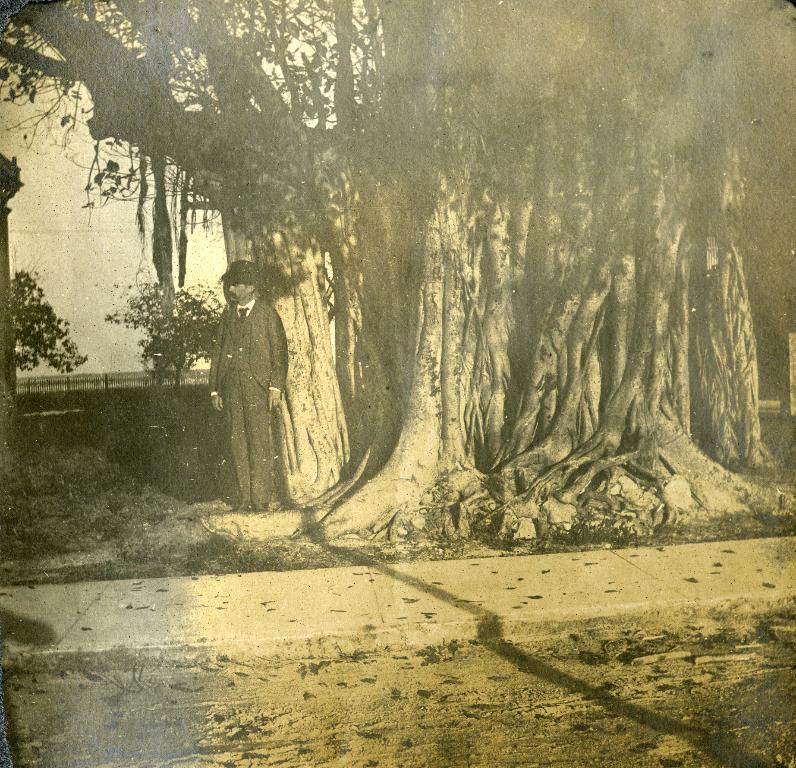Describe this image in one or two sentences. This is a black and White image in this image there is one person standing and there are some trees, and in the background there is a railing. At the bottom there is a walkway and some dry leaves. 